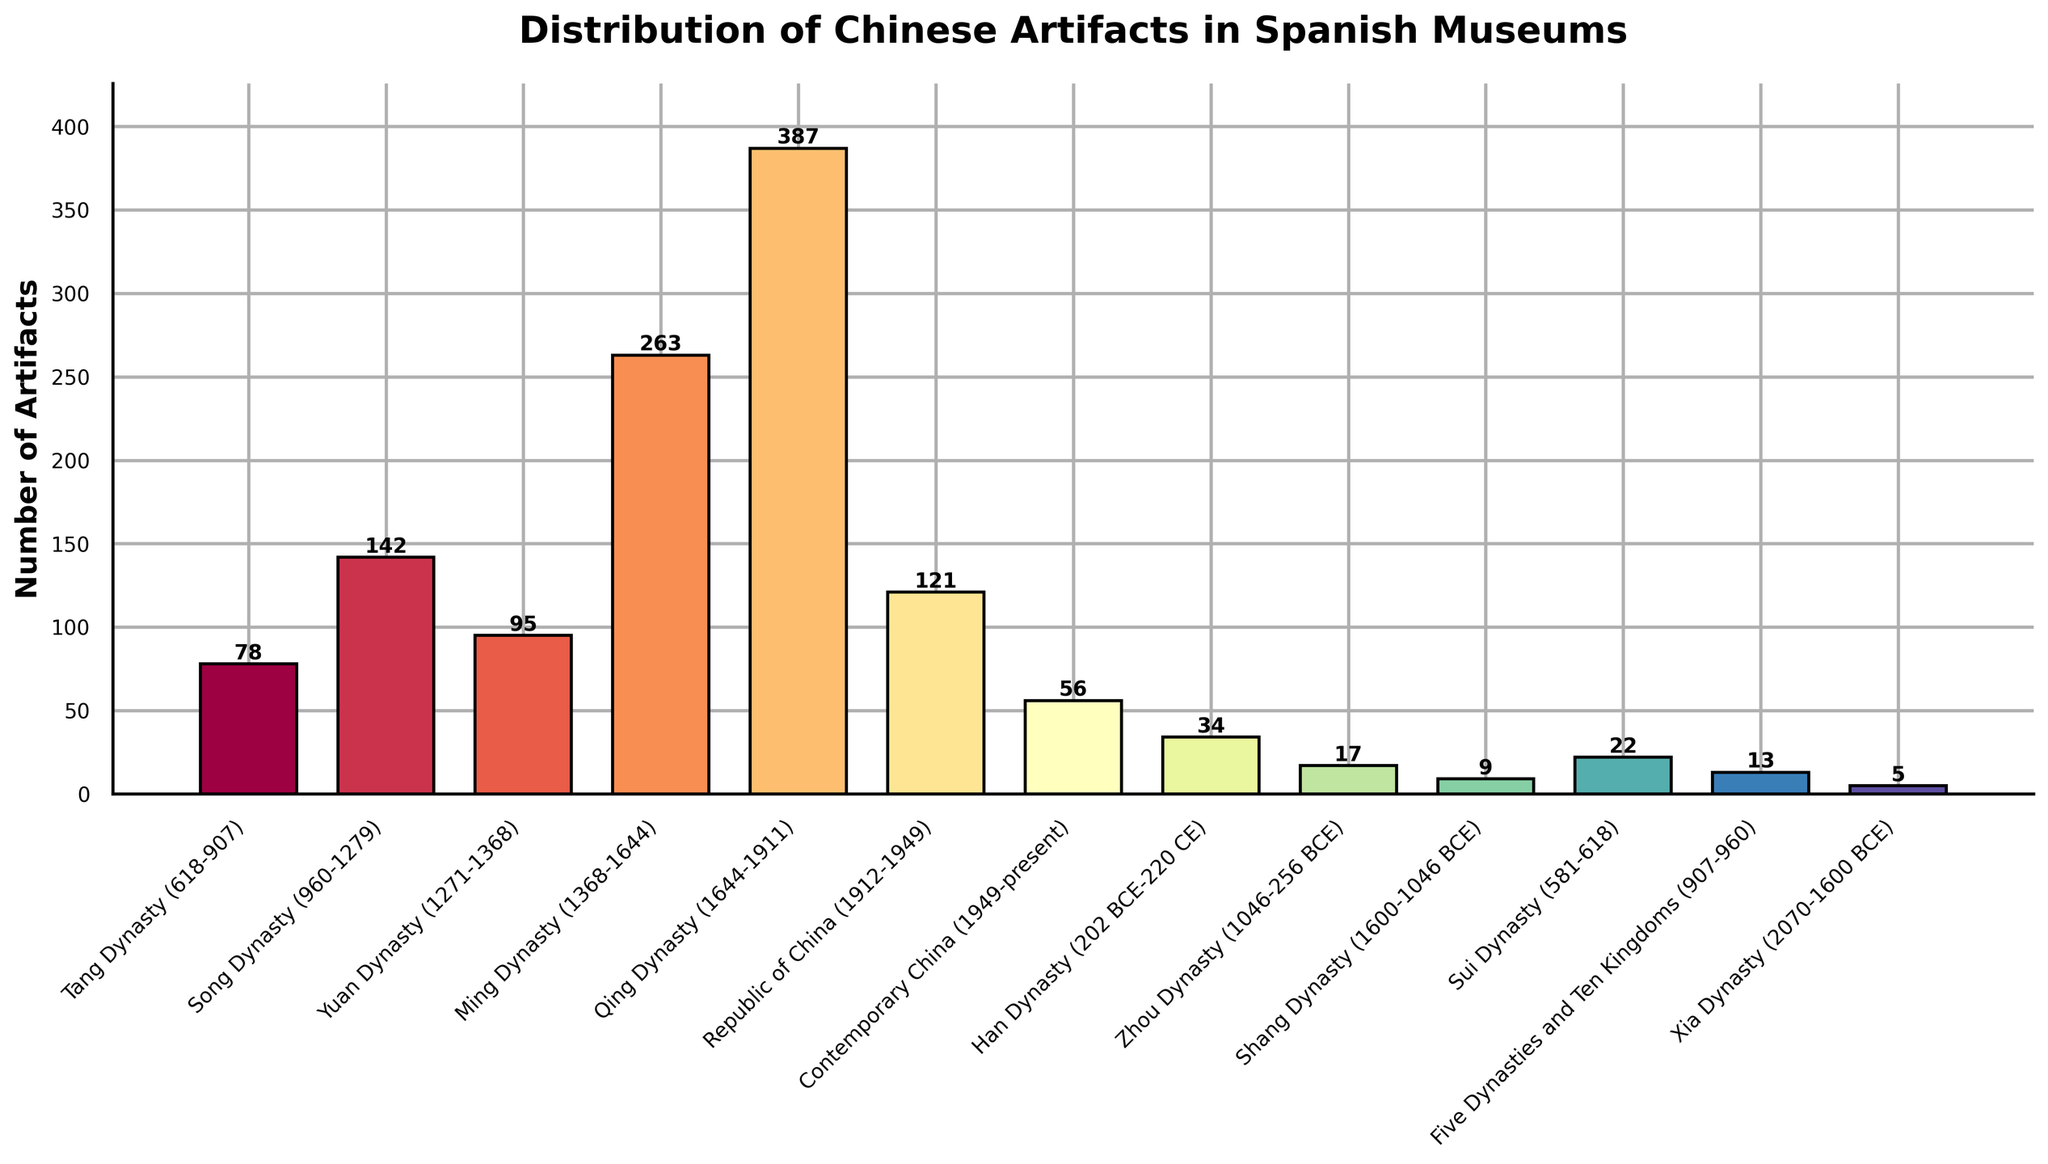Which historical period has the most number of Chinese artifacts in Spanish museums? The highest bar in the chart corresponds to the Qing Dynasty, indicating the most number of artifacts.
Answer: Qing Dynasty (1644-1911) Which historical periods have fewer than 20 artifacts? Inspecting the heights of the bars, the Zhou Dynasty, Shang Dynasty, and Xia Dynasty have fewer than 20 artifacts.
Answer: Zhou Dynasty (1046-256 BCE), Shang Dynasty (1600-1046 BCE), Xia Dynasty (2070-1600 BCE) What's the total number of artifacts from the Tang, Song, and Yuan Dynasties combined? Sum the number of artifacts from Tang (78), Song (142), and Yuan (95). 78 + 142 + 95 = 315
Answer: 315 Which two consecutive dynasties show the largest increase in the number of artifacts? Looking at the differences in bar heights, the largest increase is from the Ming Dynasty (263) to the Qing Dynasty (387), with an increase of 124.
Answer: Ming to Qing How does the number of artifacts from the Republic of China compare to the Ming Dynasty? The bar for the Republic of China (121) is shorter than the Ming Dynasty (263), indicating fewer artifacts.
Answer: Republic of China has fewer artifacts What is the average number of artifacts for the Three Dynasties (Shang, Zhou, Xia)? Calculate the average: (9 + 17 + 5) / 3. Sum is 31, average is 31 / 3 = 10.33
Answer: 10.33 Are there more artifacts from the Han Dynasty or the Sui Dynasty in Spanish museums? Comparing the bars, the Han Dynasty has 34 artifacts, while the Sui Dynasty has 22 artifacts.
Answer: Han Dynasty Which dynasty has the second-highest number of artifacts? The second-highest bar is for the Ming Dynasty with 263 artifacts, just below the Qing Dynasty.
Answer: Ming Dynasty (1368-1644) What is the difference in the number of artifacts between the Song Dynasty and the Contemporary China period? Subtract the number of artifacts in Contemporary China (56) from the Song Dynasty (142). 142 - 56 = 86
Answer: 86 What is the median value of artifacts from all historical periods? List all artifact counts (5, 9, 13, 17, 22, 34, 56, 78, 95, 121, 142, 263, 387), then find the median. The middle value in this 13-item list is 78.
Answer: 78 